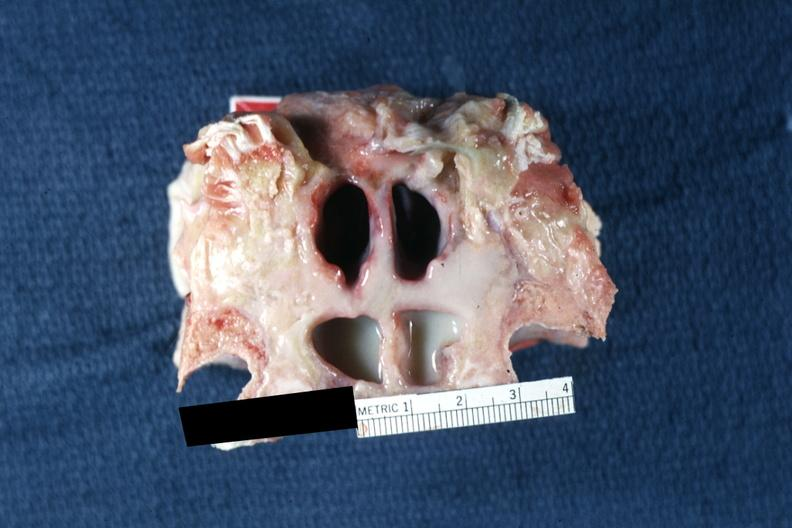what is present?
Answer the question using a single word or phrase. Purulent sinusitis 